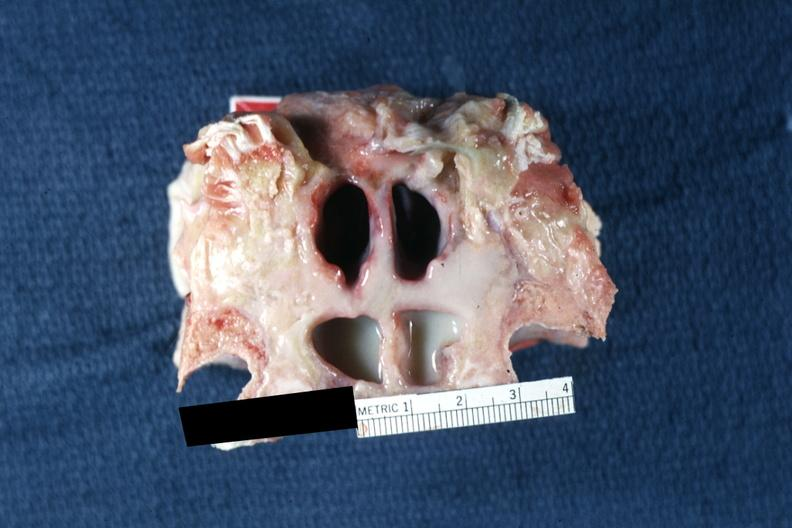what is present?
Answer the question using a single word or phrase. Purulent sinusitis 